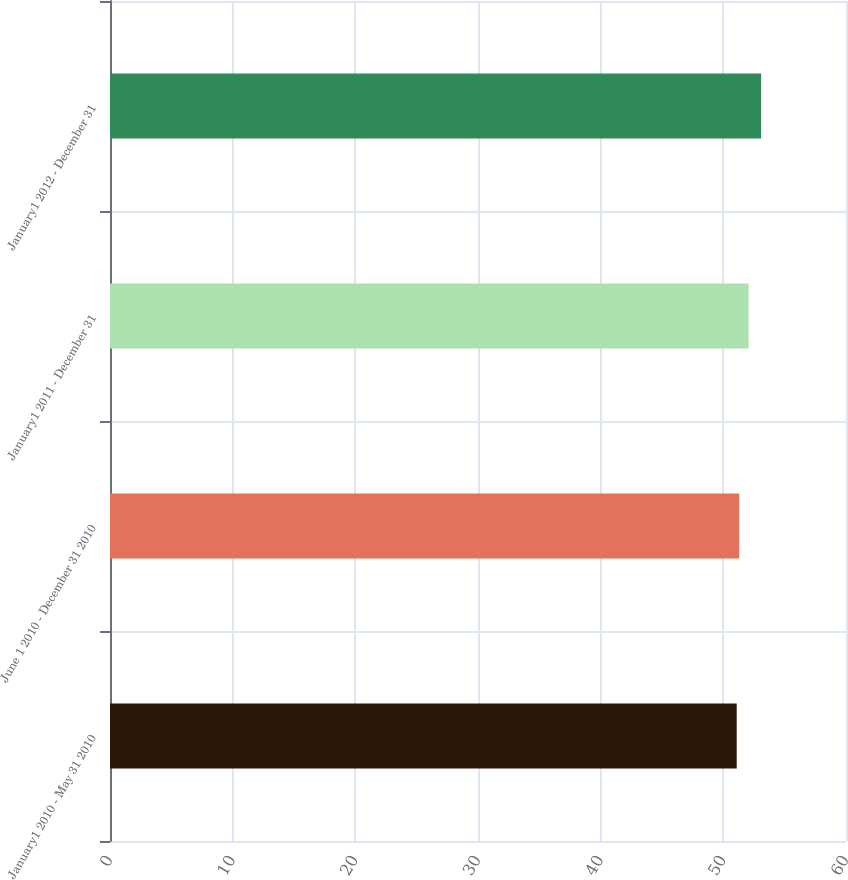Convert chart. <chart><loc_0><loc_0><loc_500><loc_500><bar_chart><fcel>January1 2010 - May 31 2010<fcel>June 1 2010 - December 31 2010<fcel>January1 2011 - December 31<fcel>January1 2012 - December 31<nl><fcel>51.09<fcel>51.29<fcel>52.06<fcel>53.08<nl></chart> 